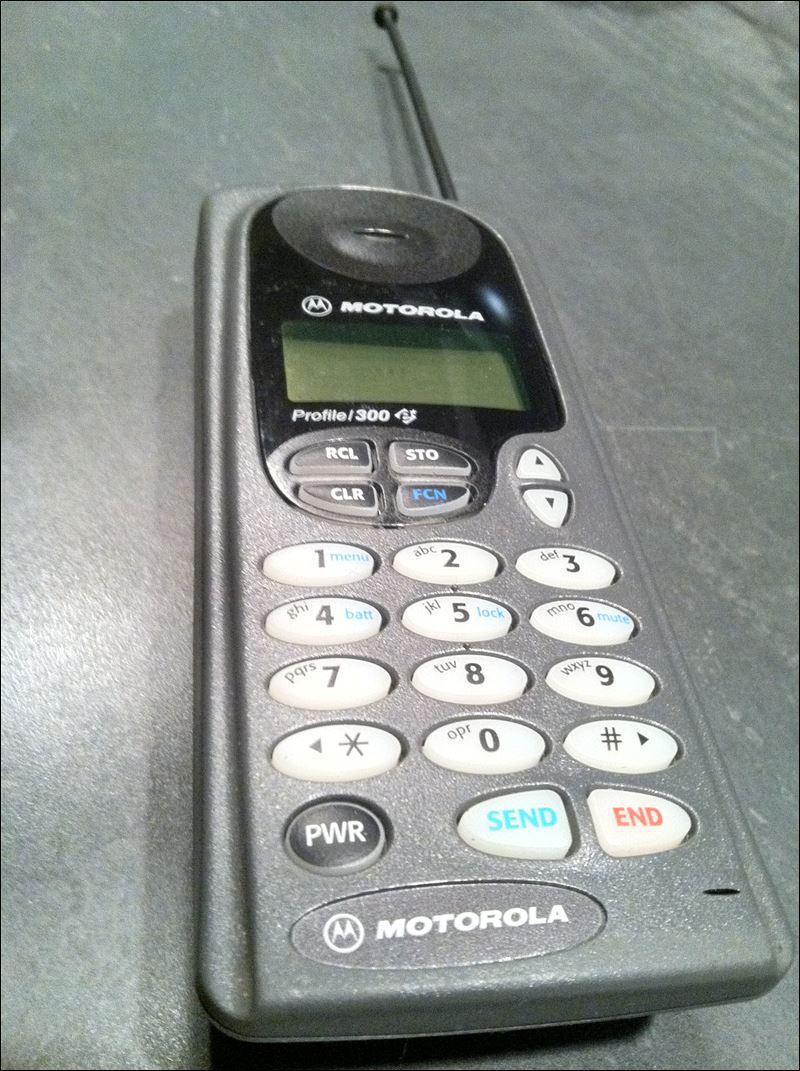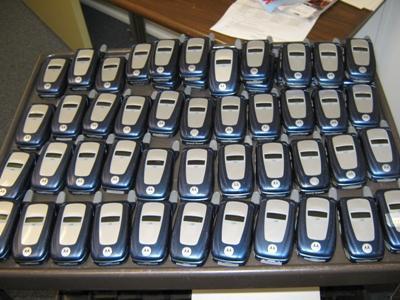The first image is the image on the left, the second image is the image on the right. Given the left and right images, does the statement "A large assortment of cell phones are seen in both images." hold true? Answer yes or no. No. The first image is the image on the left, the second image is the image on the right. Assess this claim about the two images: "In both images there are many mobile phones from a variety of brands and models.". Correct or not? Answer yes or no. No. 